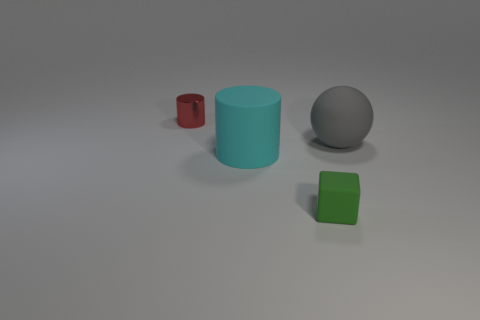What time of day does this scene represent? The lighting in the scene does not suggest a particular time of day, as it is an artificial and controlled environment, likely rendered on a computer. Is there anything about this image that suggests it might be used for something specific? The simplicity and the arrangement of geometric shapes suggest this image could be used for educational purposes like a physics simulation, graphical demonstration, or a test in color perception and spatial reasoning. 